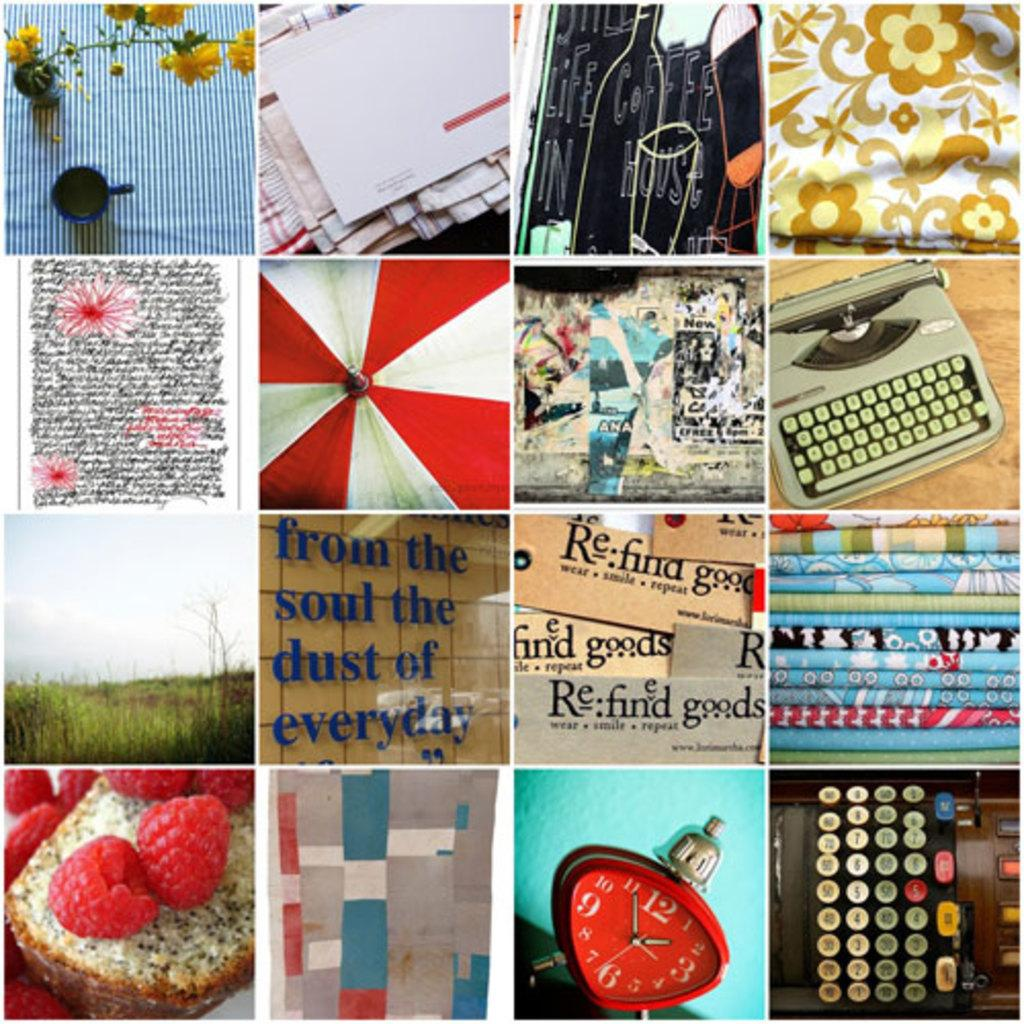<image>
Create a compact narrative representing the image presented. the word goods is on one of the many frames 